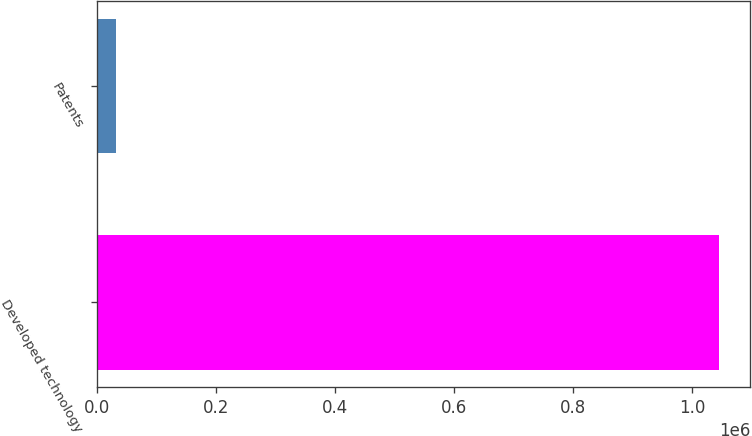<chart> <loc_0><loc_0><loc_500><loc_500><bar_chart><fcel>Developed technology<fcel>Patents<nl><fcel>1.04538e+06<fcel>32875<nl></chart> 